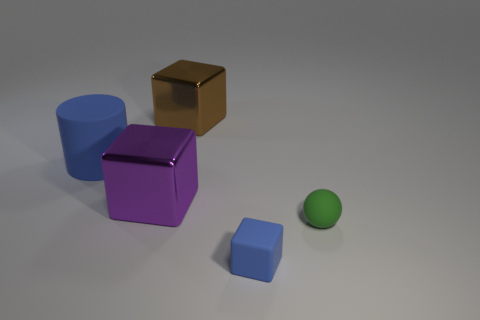There is a block that is in front of the small green sphere; does it have the same color as the large metal thing that is in front of the blue cylinder?
Your answer should be compact. No. What is the size of the block that is the same color as the large cylinder?
Keep it short and to the point. Small. Is there a green cylinder that has the same material as the blue block?
Provide a short and direct response. No. Are there an equal number of green objects on the right side of the green matte thing and big purple blocks behind the large brown metallic block?
Your response must be concise. Yes. There is a blue object that is behind the tiny green rubber object; what size is it?
Provide a short and direct response. Large. There is a small thing that is on the right side of the blue object that is in front of the ball; what is its material?
Your answer should be very brief. Rubber. How many blue matte cubes are to the left of the blue thing that is in front of the rubber object that is left of the purple metal block?
Provide a short and direct response. 0. Are the blue thing that is to the right of the blue cylinder and the blue object to the left of the big brown metal thing made of the same material?
Provide a succinct answer. Yes. There is a small object that is the same color as the matte cylinder; what material is it?
Ensure brevity in your answer.  Rubber. What number of other green matte things have the same shape as the green thing?
Offer a very short reply. 0. 